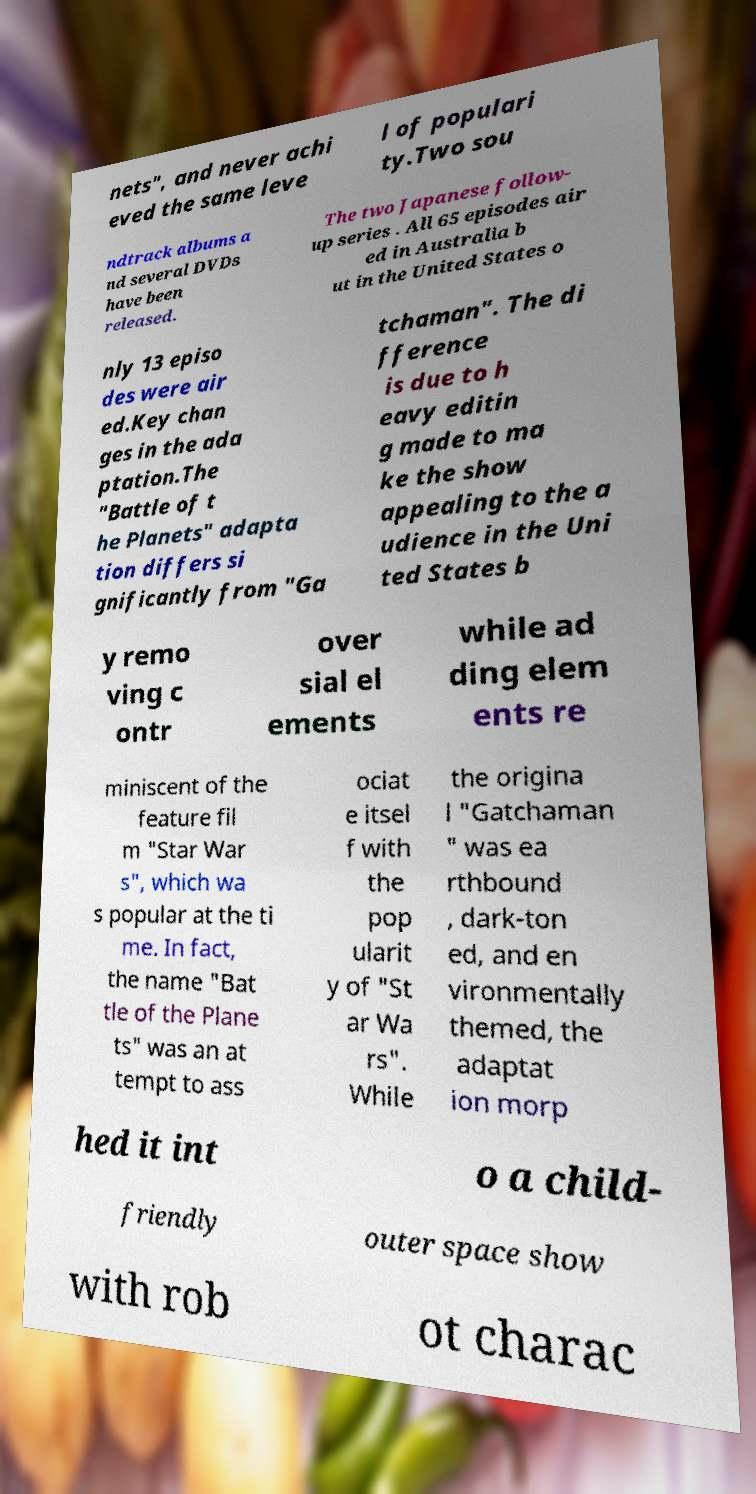I need the written content from this picture converted into text. Can you do that? nets", and never achi eved the same leve l of populari ty.Two sou ndtrack albums a nd several DVDs have been released. The two Japanese follow- up series . All 65 episodes air ed in Australia b ut in the United States o nly 13 episo des were air ed.Key chan ges in the ada ptation.The "Battle of t he Planets" adapta tion differs si gnificantly from "Ga tchaman". The di fference is due to h eavy editin g made to ma ke the show appealing to the a udience in the Uni ted States b y remo ving c ontr over sial el ements while ad ding elem ents re miniscent of the feature fil m "Star War s", which wa s popular at the ti me. In fact, the name "Bat tle of the Plane ts" was an at tempt to ass ociat e itsel f with the pop ularit y of "St ar Wa rs". While the origina l "Gatchaman " was ea rthbound , dark-ton ed, and en vironmentally themed, the adaptat ion morp hed it int o a child- friendly outer space show with rob ot charac 